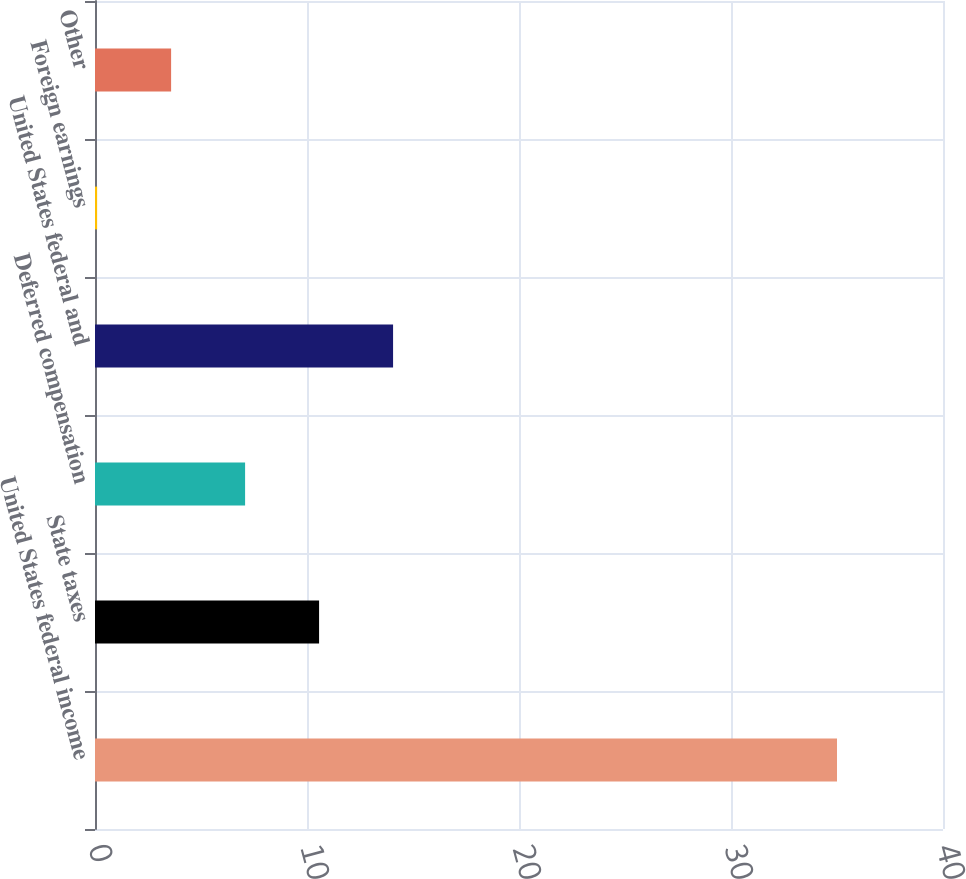<chart> <loc_0><loc_0><loc_500><loc_500><bar_chart><fcel>United States federal income<fcel>State taxes<fcel>Deferred compensation<fcel>United States federal and<fcel>Foreign earnings<fcel>Other<nl><fcel>35<fcel>10.57<fcel>7.08<fcel>14.06<fcel>0.1<fcel>3.59<nl></chart> 